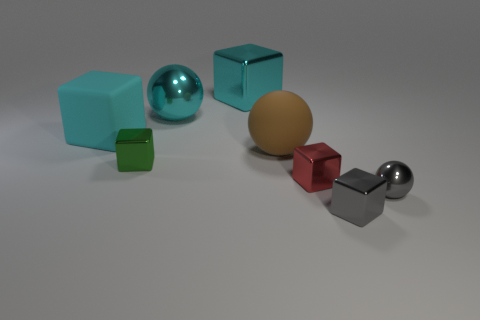Subtract 2 cubes. How many cubes are left? 3 Subtract all green cubes. How many cubes are left? 4 Subtract all brown balls. Subtract all red cylinders. How many balls are left? 2 Add 2 green things. How many objects exist? 10 Subtract all blocks. How many objects are left? 3 Subtract 0 red balls. How many objects are left? 8 Subtract all rubber spheres. Subtract all large red things. How many objects are left? 7 Add 7 large brown objects. How many large brown objects are left? 8 Add 5 big things. How many big things exist? 9 